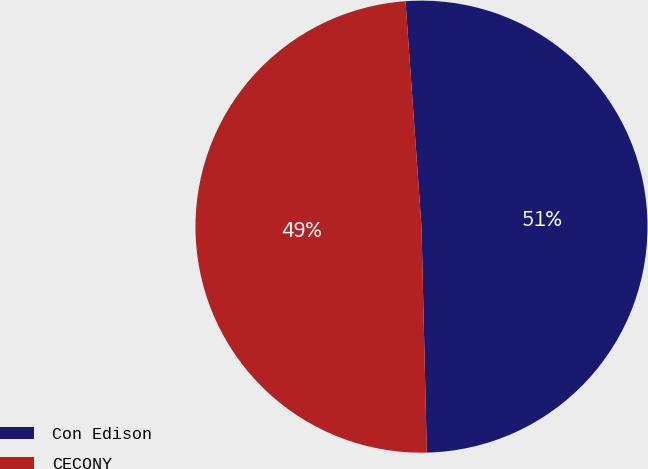Convert chart. <chart><loc_0><loc_0><loc_500><loc_500><pie_chart><fcel>Con Edison<fcel>CECONY<nl><fcel>50.75%<fcel>49.25%<nl></chart> 